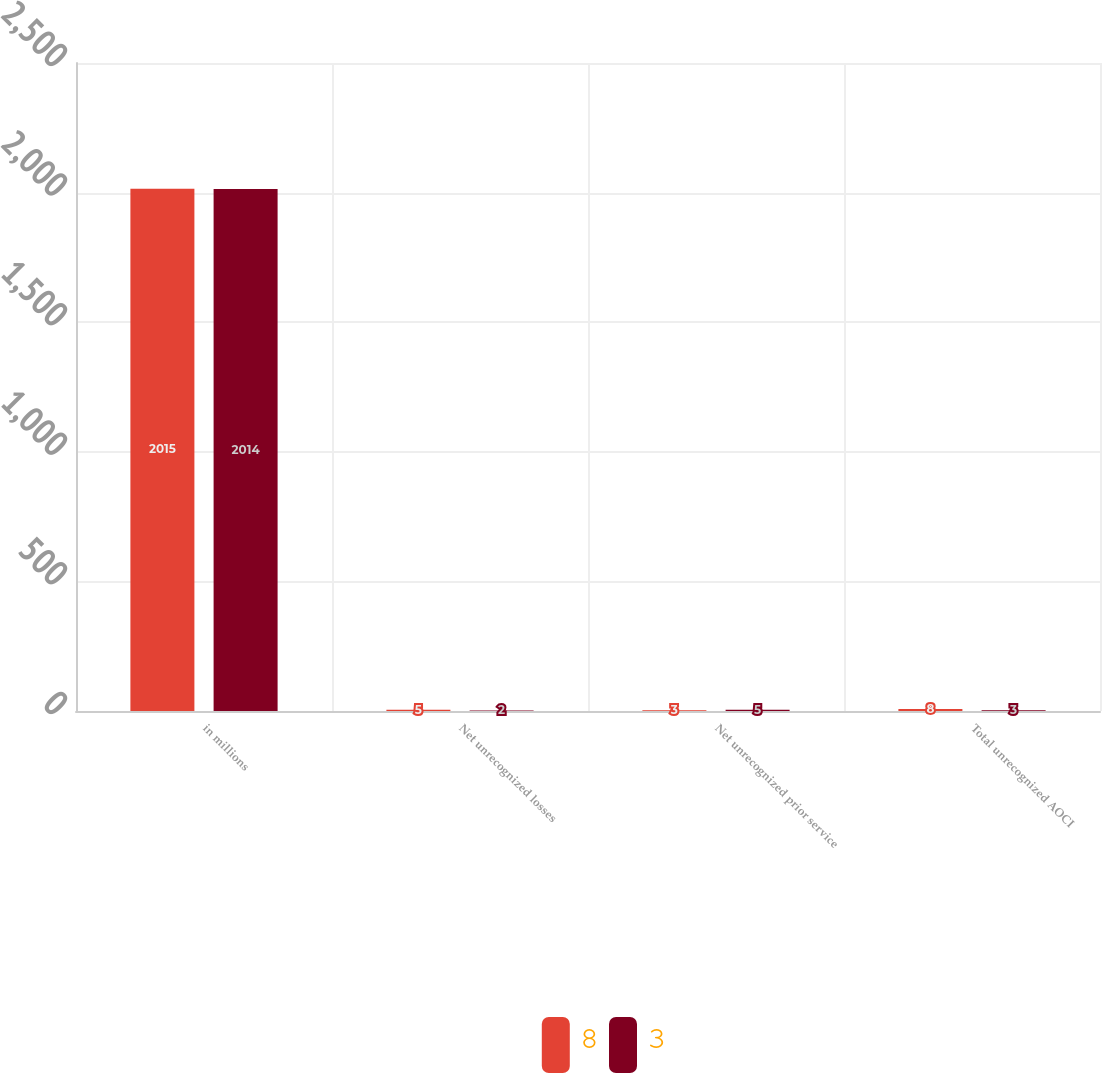Convert chart to OTSL. <chart><loc_0><loc_0><loc_500><loc_500><stacked_bar_chart><ecel><fcel>in millions<fcel>Net unrecognized losses<fcel>Net unrecognized prior service<fcel>Total unrecognized AOCI<nl><fcel>8<fcel>2015<fcel>5<fcel>3<fcel>8<nl><fcel>3<fcel>2014<fcel>2<fcel>5<fcel>3<nl></chart> 